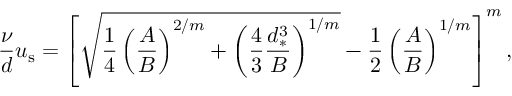Convert formula to latex. <formula><loc_0><loc_0><loc_500><loc_500>\frac { \nu } { d } u _ { s } = \left [ \sqrt { \frac { 1 } { 4 } \left ( \frac { A } { B } \right ) ^ { 2 / m } + \left ( \frac { 4 } { 3 } \frac { d _ { * } ^ { 3 } } { B } \right ) ^ { 1 / m } } - \frac { 1 } { 2 } \left ( \frac { A } { B } \right ) ^ { 1 / m } \right ] ^ { m } ,</formula> 